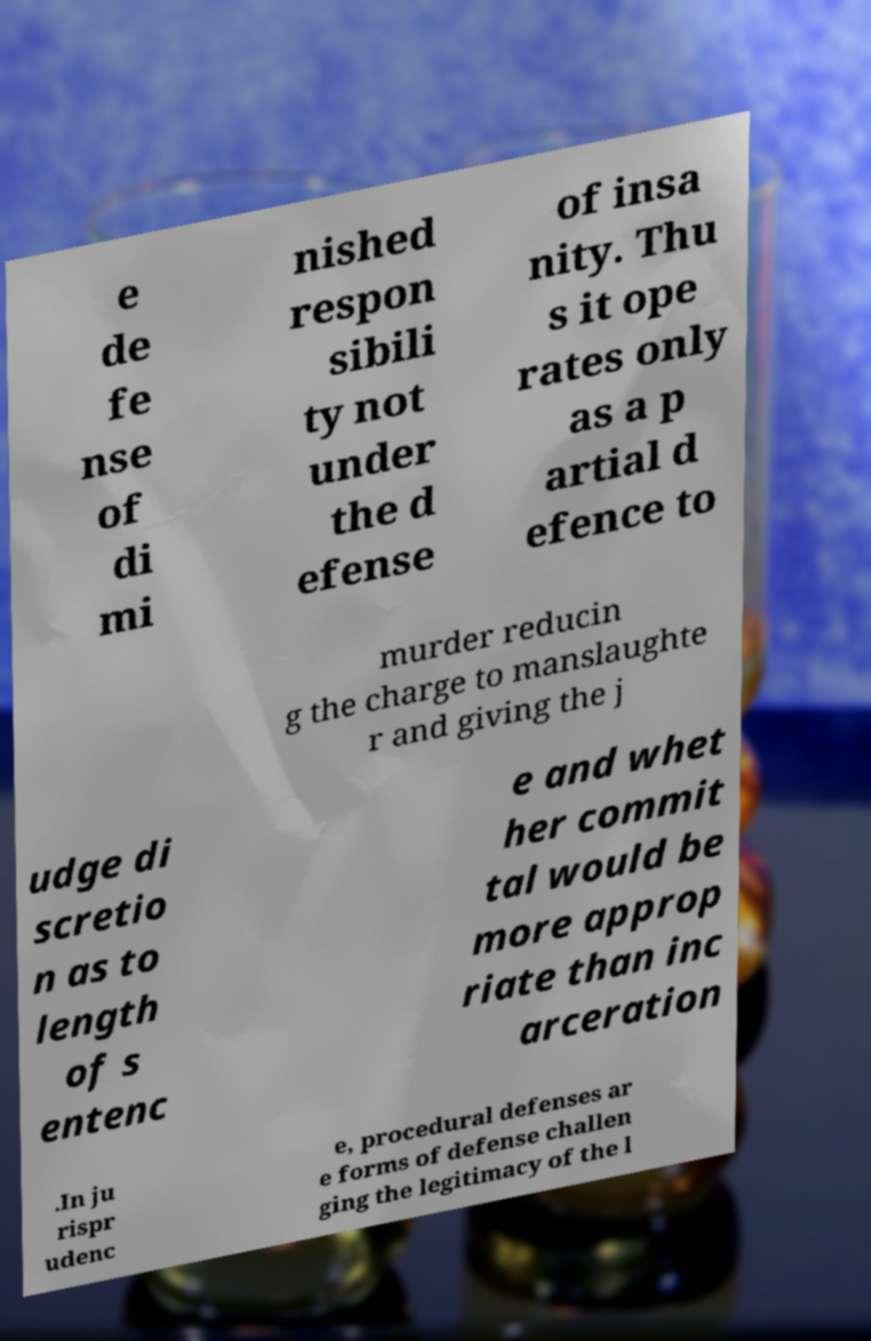What messages or text are displayed in this image? I need them in a readable, typed format. e de fe nse of di mi nished respon sibili ty not under the d efense of insa nity. Thu s it ope rates only as a p artial d efence to murder reducin g the charge to manslaughte r and giving the j udge di scretio n as to length of s entenc e and whet her commit tal would be more approp riate than inc arceration .In ju rispr udenc e, procedural defenses ar e forms of defense challen ging the legitimacy of the l 